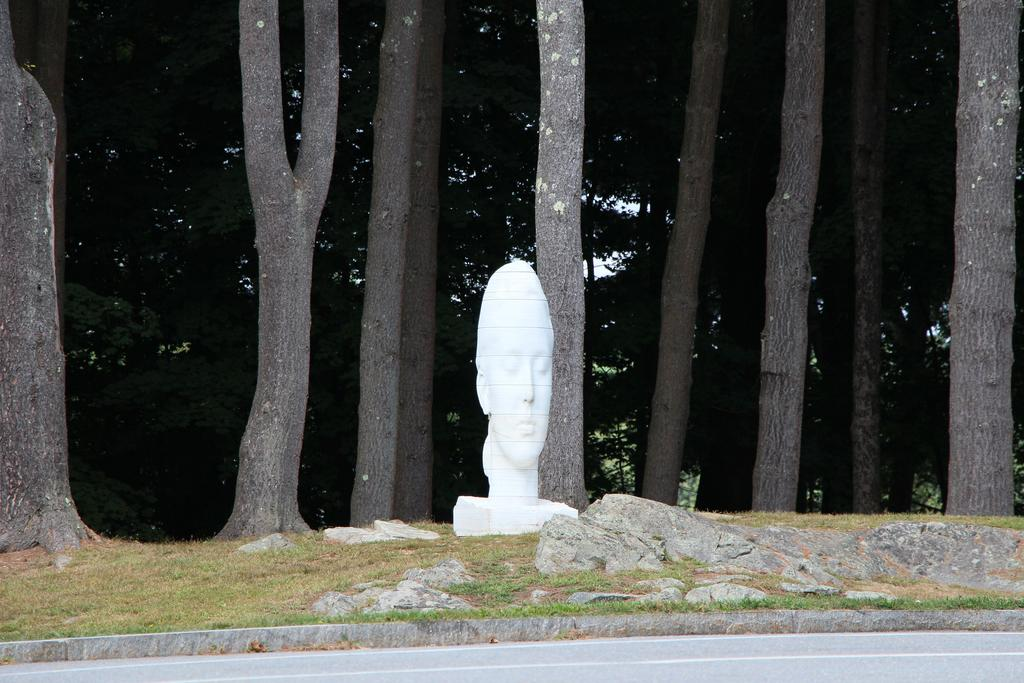What type of vegetation is present in the foreground of the picture? There is grass in the foreground of the picture. What other objects can be seen in the foreground of the picture? There are rocks, a road, and a sculpture in the foreground of the picture. What type of natural elements are visible in the background of the picture? There are trees in the background of the picture. What type of creature is attacking the sculpture in the foreground of the image? There is no creature present in the image, nor is there any indication of an attack on the sculpture. 